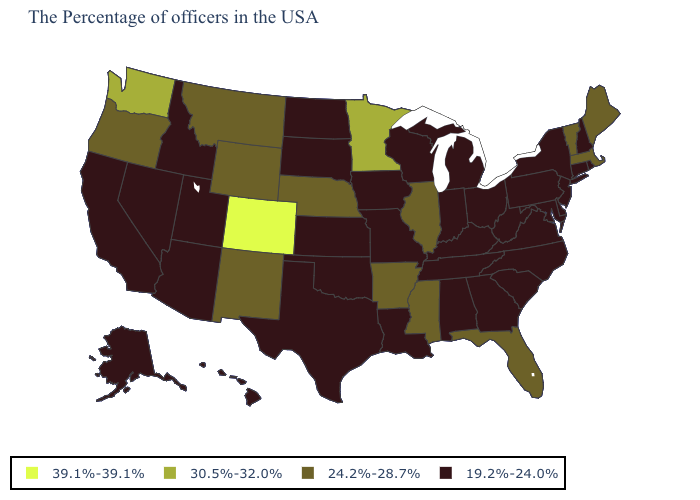What is the value of New Hampshire?
Quick response, please. 19.2%-24.0%. Does Mississippi have the same value as Wyoming?
Write a very short answer. Yes. Is the legend a continuous bar?
Give a very brief answer. No. What is the value of South Dakota?
Quick response, please. 19.2%-24.0%. Name the states that have a value in the range 19.2%-24.0%?
Answer briefly. Rhode Island, New Hampshire, Connecticut, New York, New Jersey, Delaware, Maryland, Pennsylvania, Virginia, North Carolina, South Carolina, West Virginia, Ohio, Georgia, Michigan, Kentucky, Indiana, Alabama, Tennessee, Wisconsin, Louisiana, Missouri, Iowa, Kansas, Oklahoma, Texas, South Dakota, North Dakota, Utah, Arizona, Idaho, Nevada, California, Alaska, Hawaii. Among the states that border Connecticut , which have the highest value?
Short answer required. Massachusetts. Name the states that have a value in the range 30.5%-32.0%?
Concise answer only. Minnesota, Washington. Which states have the lowest value in the MidWest?
Answer briefly. Ohio, Michigan, Indiana, Wisconsin, Missouri, Iowa, Kansas, South Dakota, North Dakota. Among the states that border Indiana , which have the lowest value?
Write a very short answer. Ohio, Michigan, Kentucky. Among the states that border Oklahoma , does Arkansas have the lowest value?
Give a very brief answer. No. Name the states that have a value in the range 24.2%-28.7%?
Write a very short answer. Maine, Massachusetts, Vermont, Florida, Illinois, Mississippi, Arkansas, Nebraska, Wyoming, New Mexico, Montana, Oregon. What is the value of Arizona?
Write a very short answer. 19.2%-24.0%. Name the states that have a value in the range 39.1%-39.1%?
Give a very brief answer. Colorado. Does North Dakota have the lowest value in the USA?
Quick response, please. Yes. 